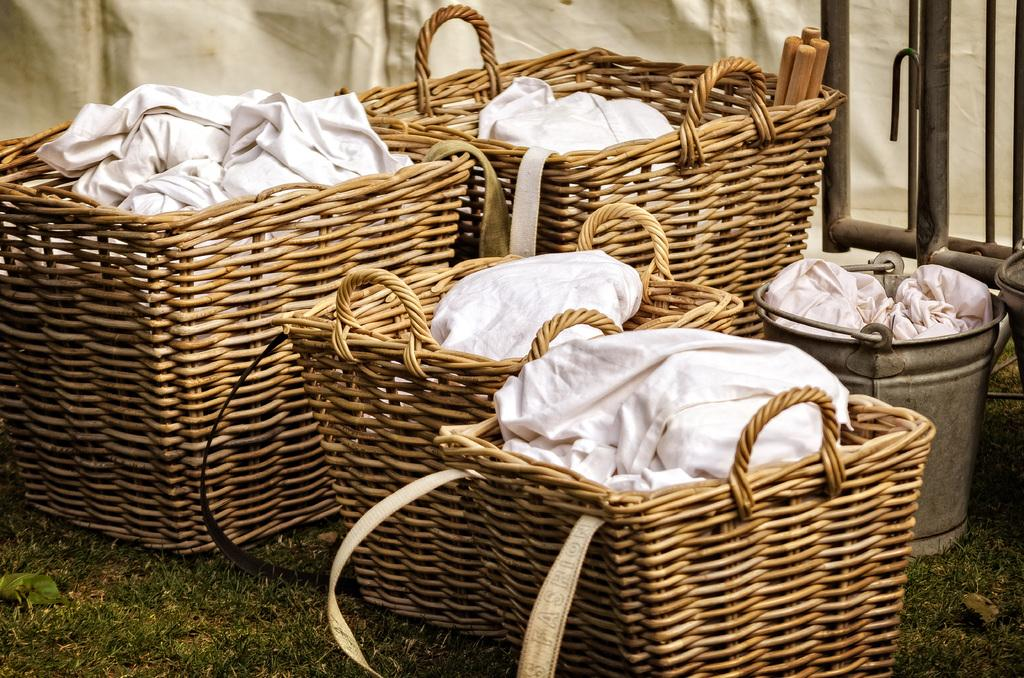What objects are present in the image that are used for holding items? There are baskets and a bucket of items in the image. Where are the baskets and bucket located? The baskets and bucket are on the grass. Can you describe the surface on which the baskets and bucket are placed? The baskets and bucket are placed on the grass. What type of waves can be seen crashing on the shore in the image? There are no waves or shore present in the image; it features baskets and a bucket on the grass. How does the debt affect the appearance of the baskets in the image? There is no mention of debt in the image, and it does not affect the appearance of the baskets. 